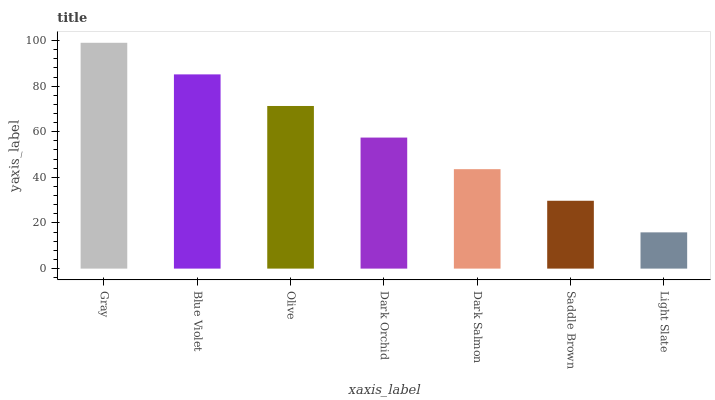Is Light Slate the minimum?
Answer yes or no. Yes. Is Gray the maximum?
Answer yes or no. Yes. Is Blue Violet the minimum?
Answer yes or no. No. Is Blue Violet the maximum?
Answer yes or no. No. Is Gray greater than Blue Violet?
Answer yes or no. Yes. Is Blue Violet less than Gray?
Answer yes or no. Yes. Is Blue Violet greater than Gray?
Answer yes or no. No. Is Gray less than Blue Violet?
Answer yes or no. No. Is Dark Orchid the high median?
Answer yes or no. Yes. Is Dark Orchid the low median?
Answer yes or no. Yes. Is Olive the high median?
Answer yes or no. No. Is Dark Salmon the low median?
Answer yes or no. No. 